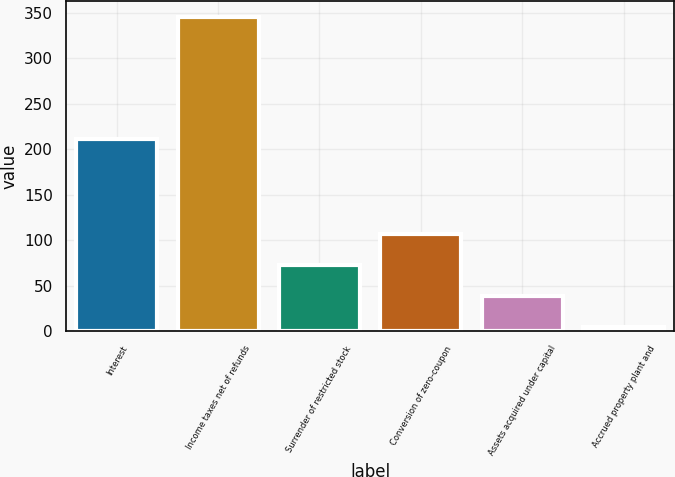Convert chart. <chart><loc_0><loc_0><loc_500><loc_500><bar_chart><fcel>Interest<fcel>Income taxes net of refunds<fcel>Surrender of restricted stock<fcel>Conversion of zero-coupon<fcel>Assets acquired under capital<fcel>Accrued property plant and<nl><fcel>210.7<fcel>345.7<fcel>72.66<fcel>106.79<fcel>38.53<fcel>4.4<nl></chart> 